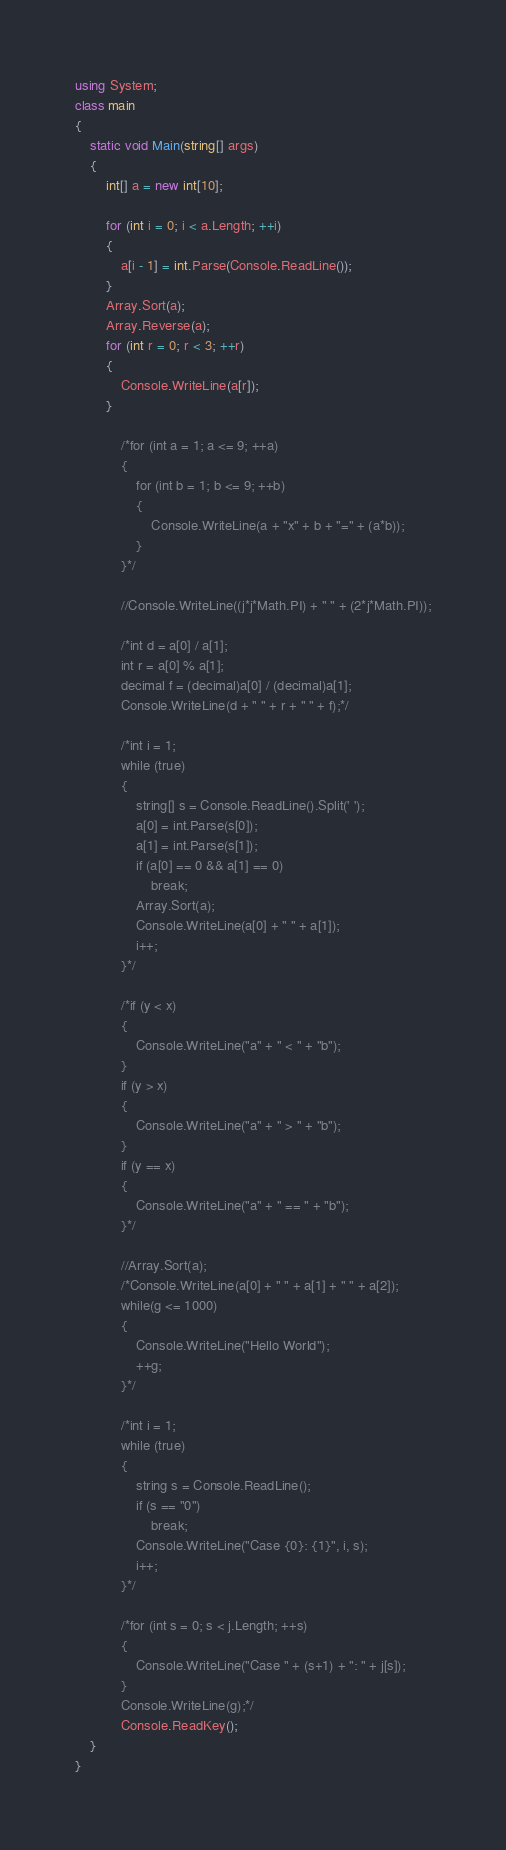Convert code to text. <code><loc_0><loc_0><loc_500><loc_500><_C#_>using System;
class main
{
    static void Main(string[] args)
    {
        int[] a = new int[10];

        for (int i = 0; i < a.Length; ++i)
        {
            a[i - 1] = int.Parse(Console.ReadLine());
        }
        Array.Sort(a);
        Array.Reverse(a);
        for (int r = 0; r < 3; ++r)
        {
            Console.WriteLine(a[r]);
        }

            /*for (int a = 1; a <= 9; ++a)
            {
                for (int b = 1; b <= 9; ++b)
                {
                    Console.WriteLine(a + "x" + b + "=" + (a*b));
                }
            }*/

            //Console.WriteLine((j*j*Math.PI) + " " + (2*j*Math.PI));

            /*int d = a[0] / a[1];
            int r = a[0] % a[1];
            decimal f = (decimal)a[0] / (decimal)a[1];
            Console.WriteLine(d + " " + r + " " + f);*/

            /*int i = 1;
            while (true)
            {
                string[] s = Console.ReadLine().Split(' ');
                a[0] = int.Parse(s[0]);
                a[1] = int.Parse(s[1]);
                if (a[0] == 0 && a[1] == 0)
                    break;
                Array.Sort(a);
                Console.WriteLine(a[0] + " " + a[1]);
                i++;
            }*/

            /*if (y < x)
            {
                Console.WriteLine("a" + " < " + "b");
            }
            if (y > x)
            {
                Console.WriteLine("a" + " > " + "b");
            }
            if (y == x)
            {
                Console.WriteLine("a" + " == " + "b");
            }*/

            //Array.Sort(a);
            /*Console.WriteLine(a[0] + " " + a[1] + " " + a[2]);
            while(g <= 1000)
            {
                Console.WriteLine("Hello World");
                ++g;
            }*/

            /*int i = 1;
            while (true)
            {
                string s = Console.ReadLine();
                if (s == "0")
                    break;
                Console.WriteLine("Case {0}: {1}", i, s);
                i++;
            }*/

            /*for (int s = 0; s < j.Length; ++s)
            {
                Console.WriteLine("Case " + (s+1) + ": " + j[s]);
            }
            Console.WriteLine(g);*/
            Console.ReadKey();
    }
}</code> 